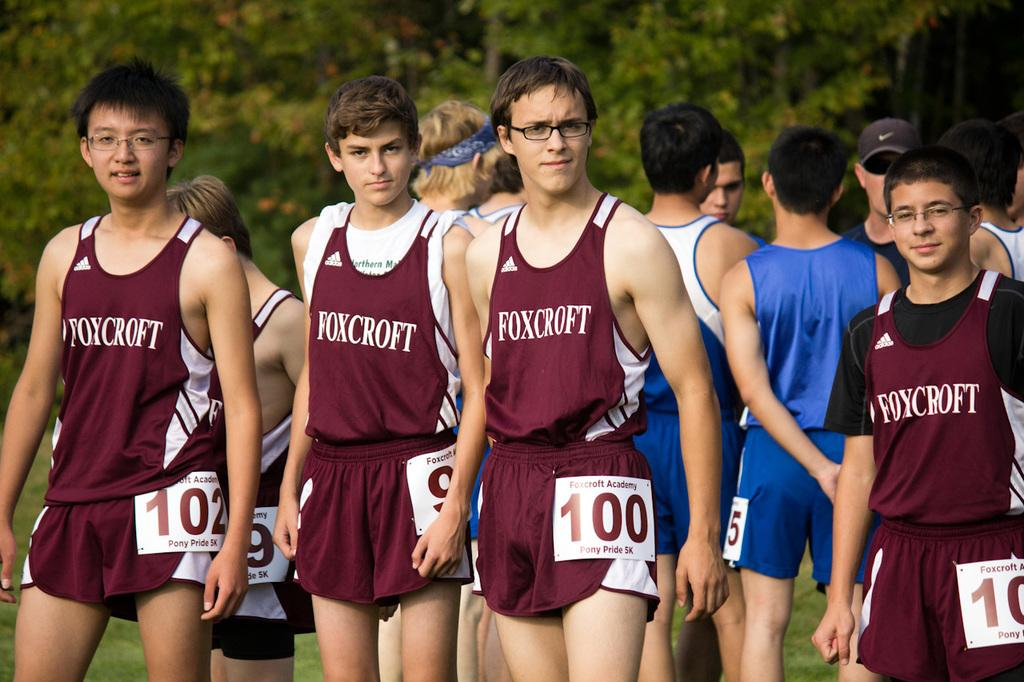Provide a one-sentence caption for the provided image. a team of young men are lined up to run a race for the Foxcroft school. 